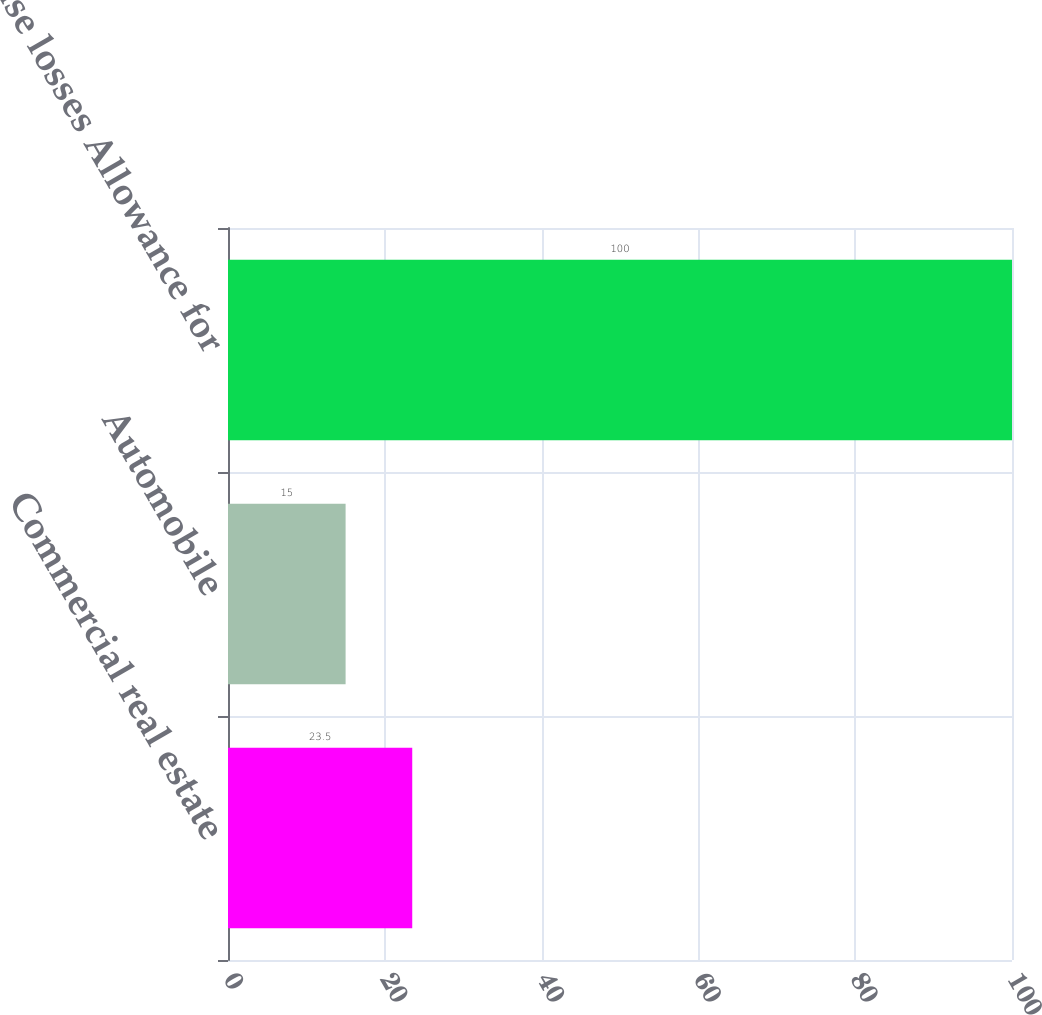Convert chart. <chart><loc_0><loc_0><loc_500><loc_500><bar_chart><fcel>Commercial real estate<fcel>Automobile<fcel>lease losses Allowance for<nl><fcel>23.5<fcel>15<fcel>100<nl></chart> 